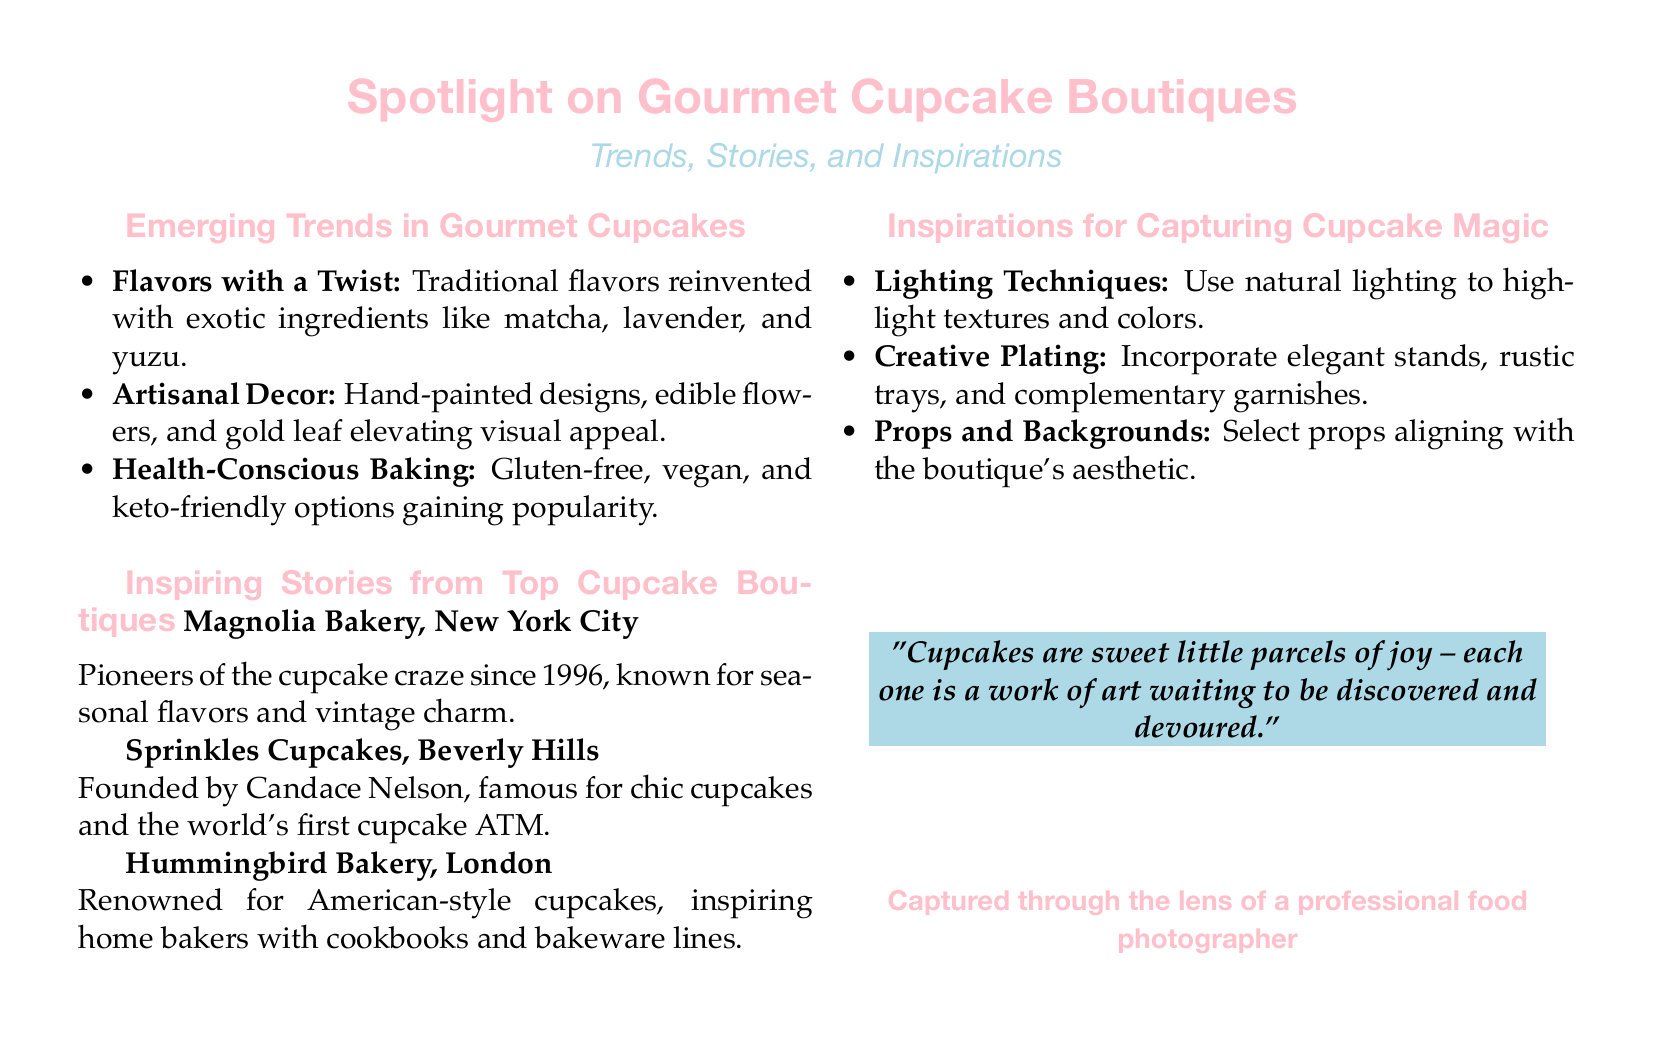What is the title of the document? The title of the document is presented at the top and is "Spotlight on Gourmet Cupcake Boutiques."
Answer: Spotlight on Gourmet Cupcake Boutiques What is the subtitle of the document? The subtitle is listed directly under the title and is "Trends, Stories, and Inspirations."
Answer: Trends, Stories, and Inspirations Which city is home to Magnolia Bakery? The text notes that Magnolia Bakery is located in New York City.
Answer: New York City What innovative feature is Sprinkles Cupcakes known for? The document highlights that Sprinkles Cupcakes is famous for the world's first cupcake ATM.
Answer: cupcake ATM What are three emerging trends mentioned in the document? The document lists flavors with a twist, artisanal decor, and health-conscious baking as trends.
Answer: flavors with a twist, artisanal decor, health-conscious baking What type of lighting is suggested for capturing cupcake images? The document recommends using natural lighting to highlight textures and colors.
Answer: natural lighting What culinary aspect does Hummingbird Bakery inspire? The text states that Hummingbird Bakery inspires home bakers with its cookbooks and bakeware lines.
Answer: cookbooks and bakeware lines Which color is associated with cupcake decorations according to the document? The document uses the term "cupcakepink" to describe a color associated with decorations.
Answer: cupcakepink Who is the founder of Sprinkles Cupcakes? The document identifies Candace Nelson as the founder of Sprinkles Cupcakes.
Answer: Candace Nelson 